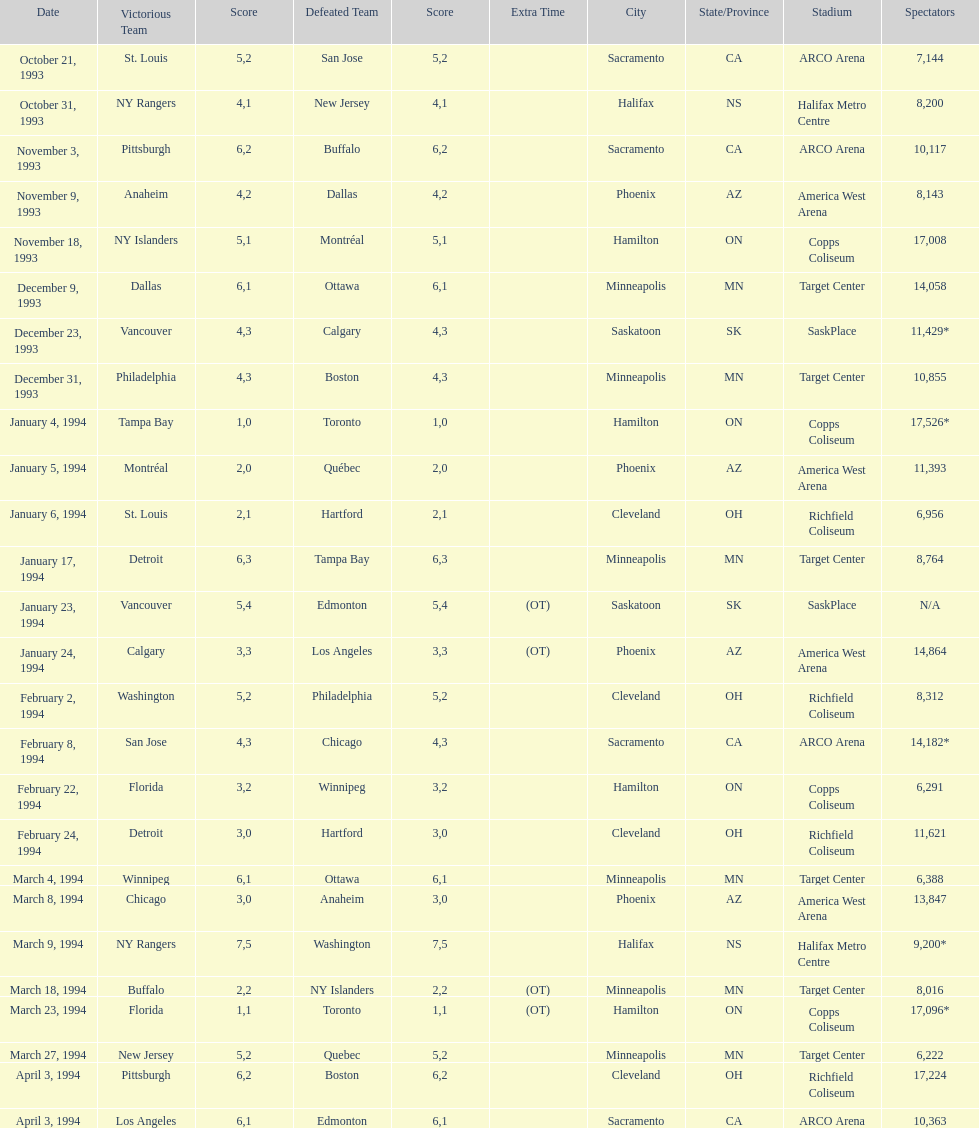Did dallas or ottawa win the december 9, 1993 game? Dallas. 